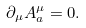<formula> <loc_0><loc_0><loc_500><loc_500>\partial _ { \mu } A _ { a } ^ { \mu } = 0 .</formula> 